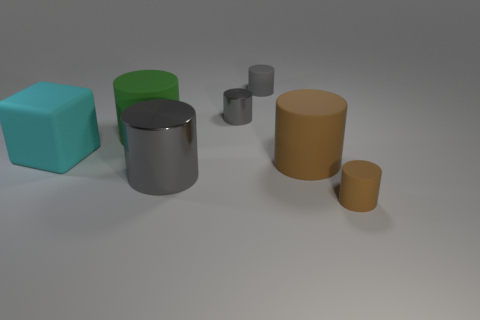How many things are either big things or big gray objects?
Make the answer very short. 4. Are there an equal number of tiny cylinders that are on the right side of the small gray shiny cylinder and small cylinders?
Give a very brief answer. No. There is a tiny rubber cylinder that is behind the small gray cylinder that is in front of the tiny gray rubber cylinder; is there a big brown rubber object right of it?
Ensure brevity in your answer.  Yes. There is a block that is made of the same material as the large green thing; what color is it?
Provide a short and direct response. Cyan. There is a metal object in front of the green cylinder; is its color the same as the small metallic cylinder?
Make the answer very short. Yes. What number of cylinders are small gray rubber objects or big brown rubber things?
Give a very brief answer. 2. There is a gray metal object that is behind the brown rubber thing that is to the left of the object that is in front of the large gray thing; what is its size?
Provide a short and direct response. Small. There is a cyan matte thing that is the same size as the green cylinder; what is its shape?
Give a very brief answer. Cube. What is the shape of the small brown matte thing?
Make the answer very short. Cylinder. Does the gray object in front of the cyan cube have the same material as the big cube?
Give a very brief answer. No. 